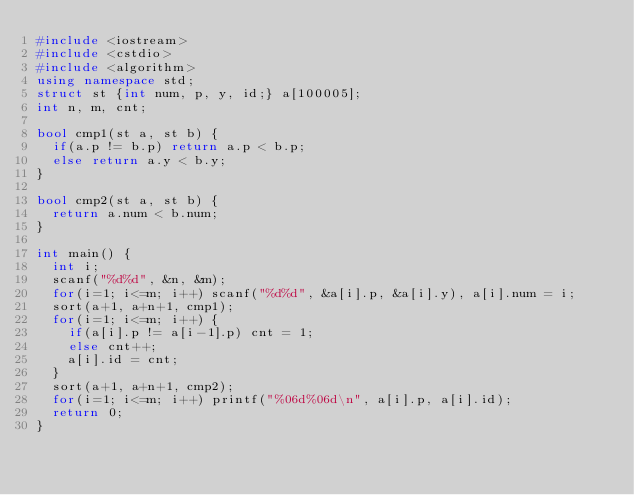Convert code to text. <code><loc_0><loc_0><loc_500><loc_500><_C++_>#include <iostream>
#include <cstdio>
#include <algorithm>
using namespace std;
struct st {int num, p, y, id;} a[100005];
int n, m, cnt;

bool cmp1(st a, st b) {
	if(a.p != b.p) return a.p < b.p;
	else return a.y < b.y;
}

bool cmp2(st a, st b) {
	return a.num < b.num;
}

int main() {
	int i;
	scanf("%d%d", &n, &m);
	for(i=1; i<=m; i++) scanf("%d%d", &a[i].p, &a[i].y), a[i].num = i;
	sort(a+1, a+n+1, cmp1);
	for(i=1; i<=m; i++) {
		if(a[i].p != a[i-1].p) cnt = 1;
		else cnt++;
		a[i].id = cnt;
	}
	sort(a+1, a+n+1, cmp2);
	for(i=1; i<=m; i++) printf("%06d%06d\n", a[i].p, a[i].id);
	return 0;
}</code> 